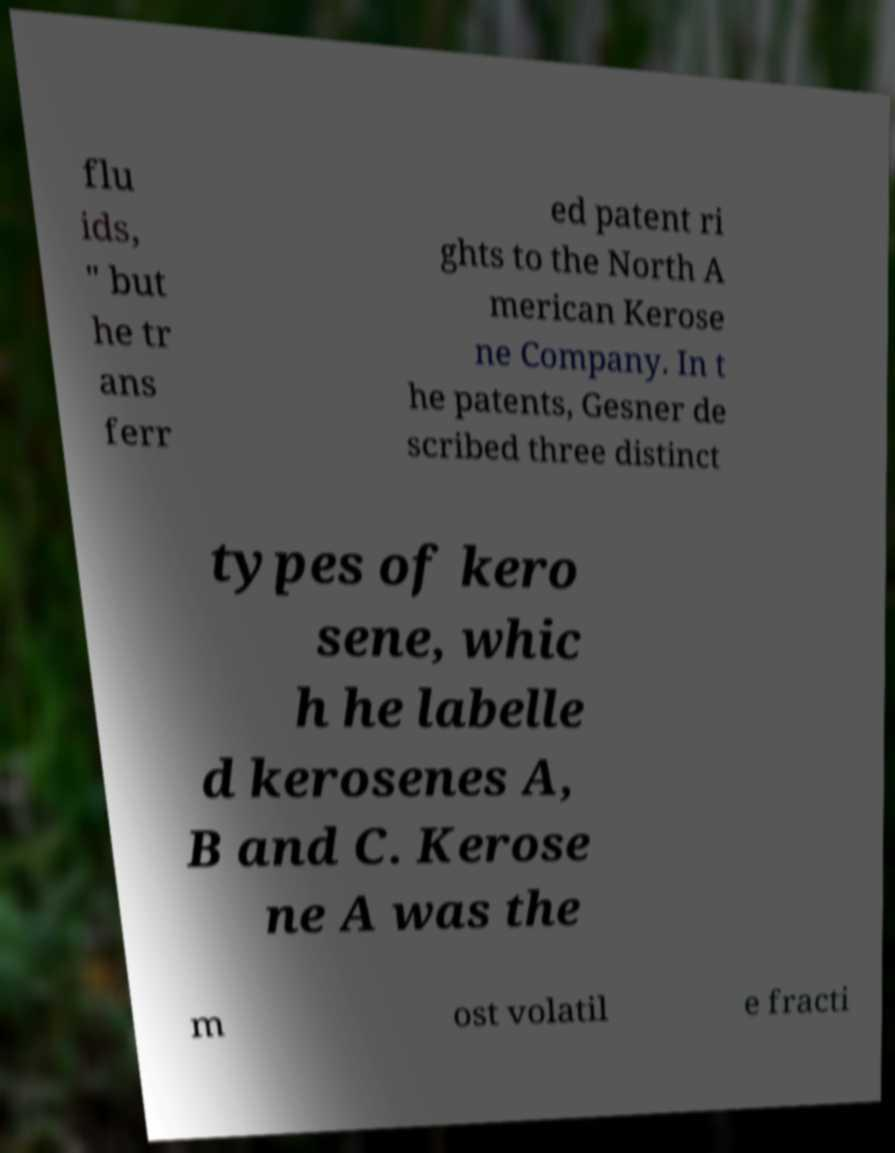For documentation purposes, I need the text within this image transcribed. Could you provide that? flu ids, " but he tr ans ferr ed patent ri ghts to the North A merican Kerose ne Company. In t he patents, Gesner de scribed three distinct types of kero sene, whic h he labelle d kerosenes A, B and C. Kerose ne A was the m ost volatil e fracti 